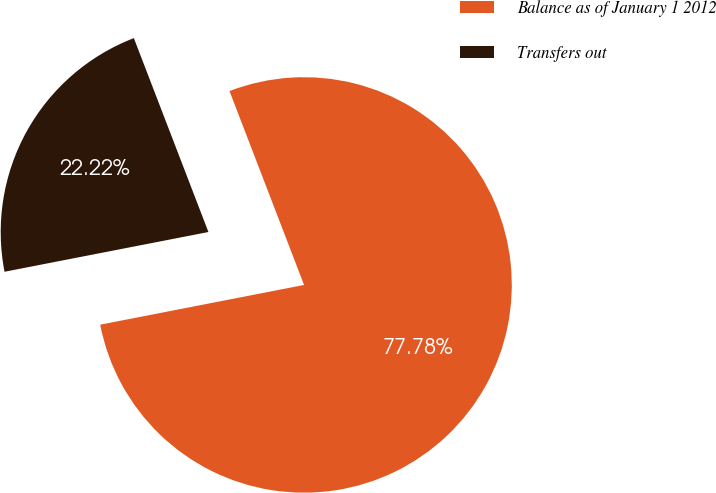<chart> <loc_0><loc_0><loc_500><loc_500><pie_chart><fcel>Balance as of January 1 2012<fcel>Transfers out<nl><fcel>77.78%<fcel>22.22%<nl></chart> 